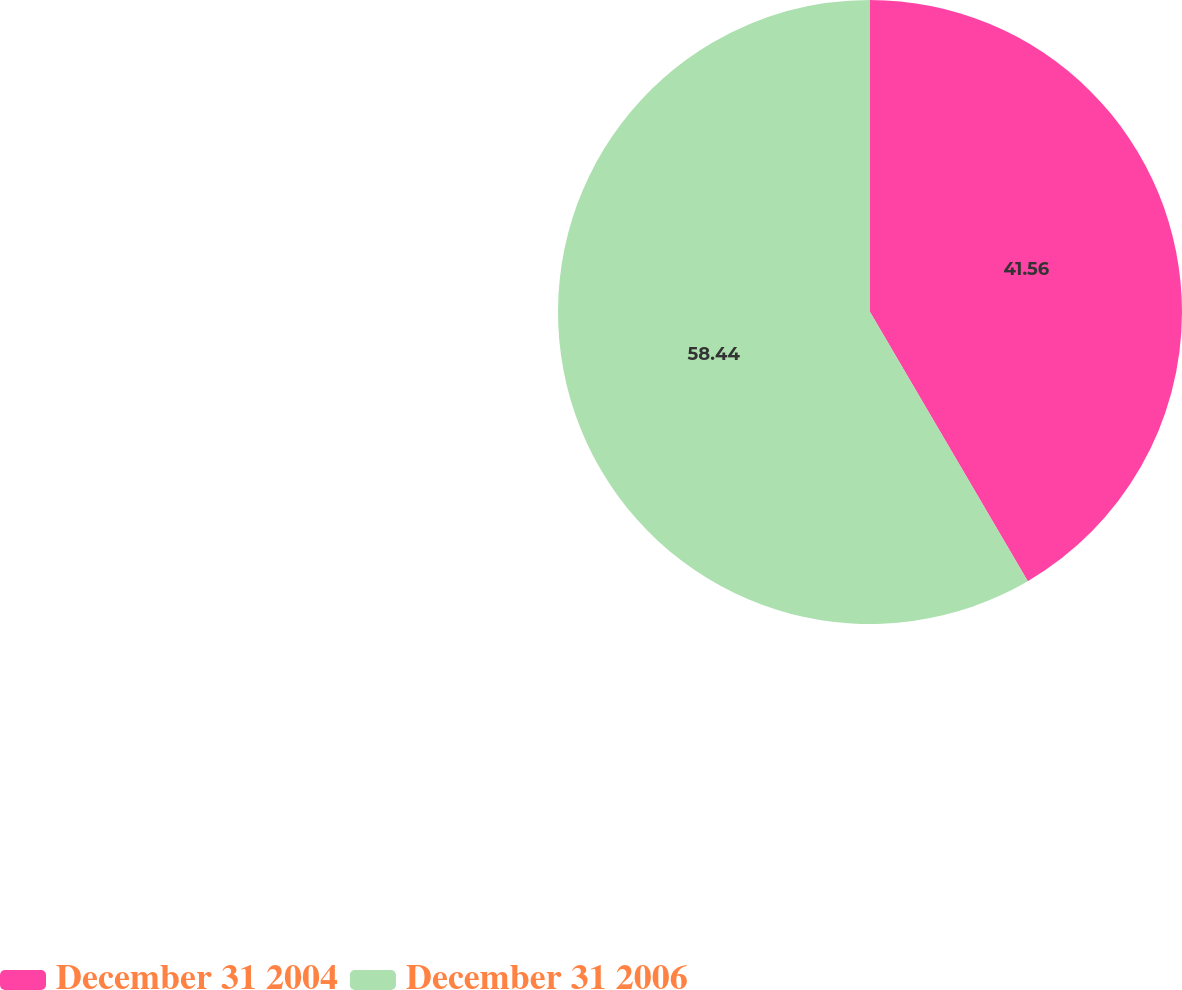Convert chart to OTSL. <chart><loc_0><loc_0><loc_500><loc_500><pie_chart><fcel>December 31 2004<fcel>December 31 2006<nl><fcel>41.56%<fcel>58.44%<nl></chart> 